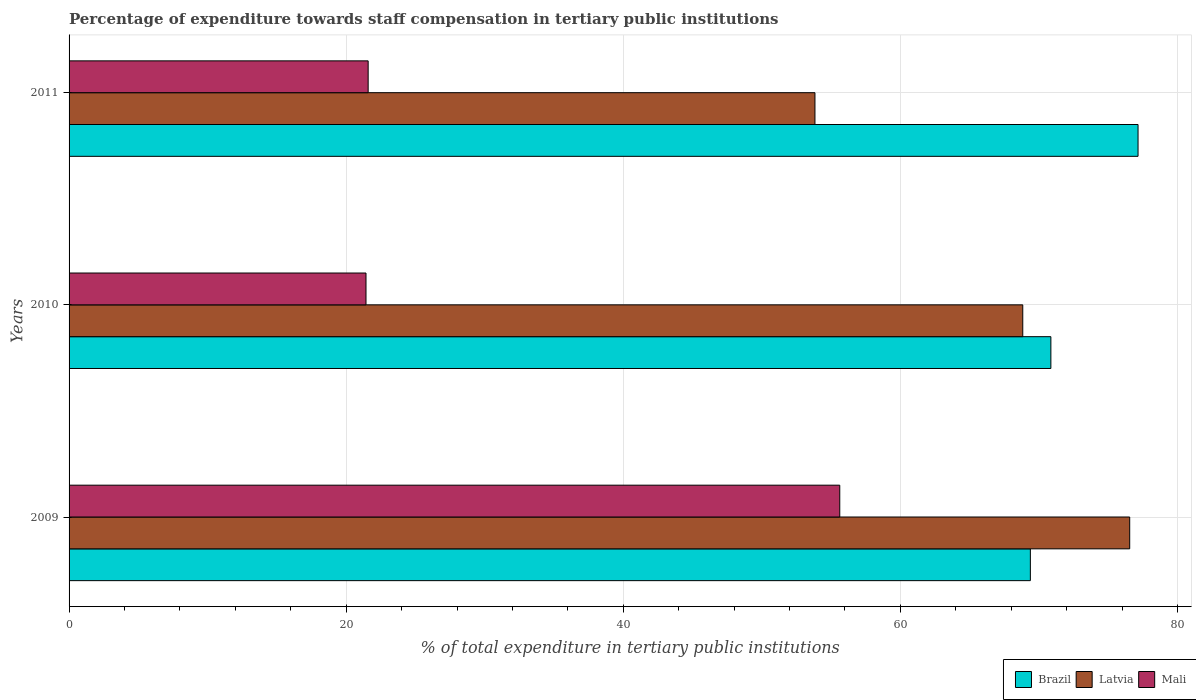How many different coloured bars are there?
Provide a short and direct response. 3. Are the number of bars on each tick of the Y-axis equal?
Offer a terse response. Yes. How many bars are there on the 3rd tick from the top?
Give a very brief answer. 3. What is the label of the 2nd group of bars from the top?
Your answer should be compact. 2010. In how many cases, is the number of bars for a given year not equal to the number of legend labels?
Your answer should be very brief. 0. What is the percentage of expenditure towards staff compensation in Mali in 2011?
Provide a succinct answer. 21.59. Across all years, what is the maximum percentage of expenditure towards staff compensation in Brazil?
Offer a very short reply. 77.16. Across all years, what is the minimum percentage of expenditure towards staff compensation in Latvia?
Offer a terse response. 53.84. In which year was the percentage of expenditure towards staff compensation in Latvia minimum?
Provide a succinct answer. 2011. What is the total percentage of expenditure towards staff compensation in Mali in the graph?
Provide a succinct answer. 98.65. What is the difference between the percentage of expenditure towards staff compensation in Latvia in 2009 and that in 2011?
Provide a succinct answer. 22.72. What is the difference between the percentage of expenditure towards staff compensation in Brazil in 2010 and the percentage of expenditure towards staff compensation in Latvia in 2009?
Offer a very short reply. -5.69. What is the average percentage of expenditure towards staff compensation in Brazil per year?
Offer a terse response. 72.47. In the year 2009, what is the difference between the percentage of expenditure towards staff compensation in Brazil and percentage of expenditure towards staff compensation in Latvia?
Give a very brief answer. -7.17. What is the ratio of the percentage of expenditure towards staff compensation in Latvia in 2009 to that in 2010?
Keep it short and to the point. 1.11. Is the percentage of expenditure towards staff compensation in Latvia in 2009 less than that in 2011?
Offer a very short reply. No. Is the difference between the percentage of expenditure towards staff compensation in Brazil in 2009 and 2010 greater than the difference between the percentage of expenditure towards staff compensation in Latvia in 2009 and 2010?
Keep it short and to the point. No. What is the difference between the highest and the second highest percentage of expenditure towards staff compensation in Brazil?
Provide a short and direct response. 6.29. What is the difference between the highest and the lowest percentage of expenditure towards staff compensation in Latvia?
Offer a terse response. 22.72. What does the 1st bar from the top in 2011 represents?
Provide a short and direct response. Mali. What does the 2nd bar from the bottom in 2009 represents?
Provide a short and direct response. Latvia. How many bars are there?
Give a very brief answer. 9. How many years are there in the graph?
Offer a very short reply. 3. What is the difference between two consecutive major ticks on the X-axis?
Offer a very short reply. 20. Are the values on the major ticks of X-axis written in scientific E-notation?
Provide a succinct answer. No. Does the graph contain grids?
Keep it short and to the point. Yes. Where does the legend appear in the graph?
Provide a short and direct response. Bottom right. How many legend labels are there?
Your response must be concise. 3. How are the legend labels stacked?
Your response must be concise. Horizontal. What is the title of the graph?
Your answer should be compact. Percentage of expenditure towards staff compensation in tertiary public institutions. What is the label or title of the X-axis?
Offer a very short reply. % of total expenditure in tertiary public institutions. What is the label or title of the Y-axis?
Your answer should be very brief. Years. What is the % of total expenditure in tertiary public institutions of Brazil in 2009?
Your answer should be very brief. 69.39. What is the % of total expenditure in tertiary public institutions in Latvia in 2009?
Make the answer very short. 76.56. What is the % of total expenditure in tertiary public institutions of Mali in 2009?
Offer a terse response. 55.63. What is the % of total expenditure in tertiary public institutions of Brazil in 2010?
Ensure brevity in your answer.  70.87. What is the % of total expenditure in tertiary public institutions of Latvia in 2010?
Your answer should be very brief. 68.84. What is the % of total expenditure in tertiary public institutions of Mali in 2010?
Your answer should be compact. 21.43. What is the % of total expenditure in tertiary public institutions in Brazil in 2011?
Give a very brief answer. 77.16. What is the % of total expenditure in tertiary public institutions of Latvia in 2011?
Make the answer very short. 53.84. What is the % of total expenditure in tertiary public institutions of Mali in 2011?
Provide a succinct answer. 21.59. Across all years, what is the maximum % of total expenditure in tertiary public institutions in Brazil?
Provide a succinct answer. 77.16. Across all years, what is the maximum % of total expenditure in tertiary public institutions of Latvia?
Keep it short and to the point. 76.56. Across all years, what is the maximum % of total expenditure in tertiary public institutions in Mali?
Keep it short and to the point. 55.63. Across all years, what is the minimum % of total expenditure in tertiary public institutions in Brazil?
Your answer should be compact. 69.39. Across all years, what is the minimum % of total expenditure in tertiary public institutions of Latvia?
Offer a terse response. 53.84. Across all years, what is the minimum % of total expenditure in tertiary public institutions of Mali?
Make the answer very short. 21.43. What is the total % of total expenditure in tertiary public institutions of Brazil in the graph?
Offer a terse response. 217.41. What is the total % of total expenditure in tertiary public institutions in Latvia in the graph?
Offer a terse response. 199.23. What is the total % of total expenditure in tertiary public institutions of Mali in the graph?
Make the answer very short. 98.65. What is the difference between the % of total expenditure in tertiary public institutions in Brazil in 2009 and that in 2010?
Provide a succinct answer. -1.48. What is the difference between the % of total expenditure in tertiary public institutions in Latvia in 2009 and that in 2010?
Your response must be concise. 7.72. What is the difference between the % of total expenditure in tertiary public institutions in Mali in 2009 and that in 2010?
Provide a short and direct response. 34.2. What is the difference between the % of total expenditure in tertiary public institutions of Brazil in 2009 and that in 2011?
Your answer should be very brief. -7.77. What is the difference between the % of total expenditure in tertiary public institutions in Latvia in 2009 and that in 2011?
Your answer should be very brief. 22.72. What is the difference between the % of total expenditure in tertiary public institutions of Mali in 2009 and that in 2011?
Ensure brevity in your answer.  34.04. What is the difference between the % of total expenditure in tertiary public institutions in Brazil in 2010 and that in 2011?
Offer a terse response. -6.29. What is the difference between the % of total expenditure in tertiary public institutions in Latvia in 2010 and that in 2011?
Provide a succinct answer. 15. What is the difference between the % of total expenditure in tertiary public institutions in Mali in 2010 and that in 2011?
Provide a succinct answer. -0.16. What is the difference between the % of total expenditure in tertiary public institutions in Brazil in 2009 and the % of total expenditure in tertiary public institutions in Latvia in 2010?
Give a very brief answer. 0.55. What is the difference between the % of total expenditure in tertiary public institutions of Brazil in 2009 and the % of total expenditure in tertiary public institutions of Mali in 2010?
Provide a succinct answer. 47.95. What is the difference between the % of total expenditure in tertiary public institutions in Latvia in 2009 and the % of total expenditure in tertiary public institutions in Mali in 2010?
Offer a very short reply. 55.12. What is the difference between the % of total expenditure in tertiary public institutions in Brazil in 2009 and the % of total expenditure in tertiary public institutions in Latvia in 2011?
Provide a succinct answer. 15.55. What is the difference between the % of total expenditure in tertiary public institutions of Brazil in 2009 and the % of total expenditure in tertiary public institutions of Mali in 2011?
Give a very brief answer. 47.8. What is the difference between the % of total expenditure in tertiary public institutions in Latvia in 2009 and the % of total expenditure in tertiary public institutions in Mali in 2011?
Your response must be concise. 54.97. What is the difference between the % of total expenditure in tertiary public institutions of Brazil in 2010 and the % of total expenditure in tertiary public institutions of Latvia in 2011?
Give a very brief answer. 17.03. What is the difference between the % of total expenditure in tertiary public institutions of Brazil in 2010 and the % of total expenditure in tertiary public institutions of Mali in 2011?
Your response must be concise. 49.28. What is the difference between the % of total expenditure in tertiary public institutions in Latvia in 2010 and the % of total expenditure in tertiary public institutions in Mali in 2011?
Offer a very short reply. 47.25. What is the average % of total expenditure in tertiary public institutions in Brazil per year?
Offer a terse response. 72.47. What is the average % of total expenditure in tertiary public institutions in Latvia per year?
Make the answer very short. 66.41. What is the average % of total expenditure in tertiary public institutions of Mali per year?
Your answer should be very brief. 32.88. In the year 2009, what is the difference between the % of total expenditure in tertiary public institutions of Brazil and % of total expenditure in tertiary public institutions of Latvia?
Make the answer very short. -7.17. In the year 2009, what is the difference between the % of total expenditure in tertiary public institutions in Brazil and % of total expenditure in tertiary public institutions in Mali?
Make the answer very short. 13.76. In the year 2009, what is the difference between the % of total expenditure in tertiary public institutions of Latvia and % of total expenditure in tertiary public institutions of Mali?
Offer a very short reply. 20.93. In the year 2010, what is the difference between the % of total expenditure in tertiary public institutions of Brazil and % of total expenditure in tertiary public institutions of Latvia?
Ensure brevity in your answer.  2.03. In the year 2010, what is the difference between the % of total expenditure in tertiary public institutions of Brazil and % of total expenditure in tertiary public institutions of Mali?
Keep it short and to the point. 49.43. In the year 2010, what is the difference between the % of total expenditure in tertiary public institutions of Latvia and % of total expenditure in tertiary public institutions of Mali?
Ensure brevity in your answer.  47.4. In the year 2011, what is the difference between the % of total expenditure in tertiary public institutions in Brazil and % of total expenditure in tertiary public institutions in Latvia?
Provide a succinct answer. 23.32. In the year 2011, what is the difference between the % of total expenditure in tertiary public institutions of Brazil and % of total expenditure in tertiary public institutions of Mali?
Make the answer very short. 55.57. In the year 2011, what is the difference between the % of total expenditure in tertiary public institutions of Latvia and % of total expenditure in tertiary public institutions of Mali?
Ensure brevity in your answer.  32.25. What is the ratio of the % of total expenditure in tertiary public institutions of Brazil in 2009 to that in 2010?
Your response must be concise. 0.98. What is the ratio of the % of total expenditure in tertiary public institutions in Latvia in 2009 to that in 2010?
Make the answer very short. 1.11. What is the ratio of the % of total expenditure in tertiary public institutions in Mali in 2009 to that in 2010?
Ensure brevity in your answer.  2.6. What is the ratio of the % of total expenditure in tertiary public institutions in Brazil in 2009 to that in 2011?
Offer a terse response. 0.9. What is the ratio of the % of total expenditure in tertiary public institutions of Latvia in 2009 to that in 2011?
Make the answer very short. 1.42. What is the ratio of the % of total expenditure in tertiary public institutions in Mali in 2009 to that in 2011?
Give a very brief answer. 2.58. What is the ratio of the % of total expenditure in tertiary public institutions in Brazil in 2010 to that in 2011?
Make the answer very short. 0.92. What is the ratio of the % of total expenditure in tertiary public institutions of Latvia in 2010 to that in 2011?
Your answer should be compact. 1.28. What is the ratio of the % of total expenditure in tertiary public institutions in Mali in 2010 to that in 2011?
Provide a succinct answer. 0.99. What is the difference between the highest and the second highest % of total expenditure in tertiary public institutions in Brazil?
Keep it short and to the point. 6.29. What is the difference between the highest and the second highest % of total expenditure in tertiary public institutions in Latvia?
Your response must be concise. 7.72. What is the difference between the highest and the second highest % of total expenditure in tertiary public institutions of Mali?
Keep it short and to the point. 34.04. What is the difference between the highest and the lowest % of total expenditure in tertiary public institutions in Brazil?
Ensure brevity in your answer.  7.77. What is the difference between the highest and the lowest % of total expenditure in tertiary public institutions of Latvia?
Ensure brevity in your answer.  22.72. What is the difference between the highest and the lowest % of total expenditure in tertiary public institutions of Mali?
Your response must be concise. 34.2. 